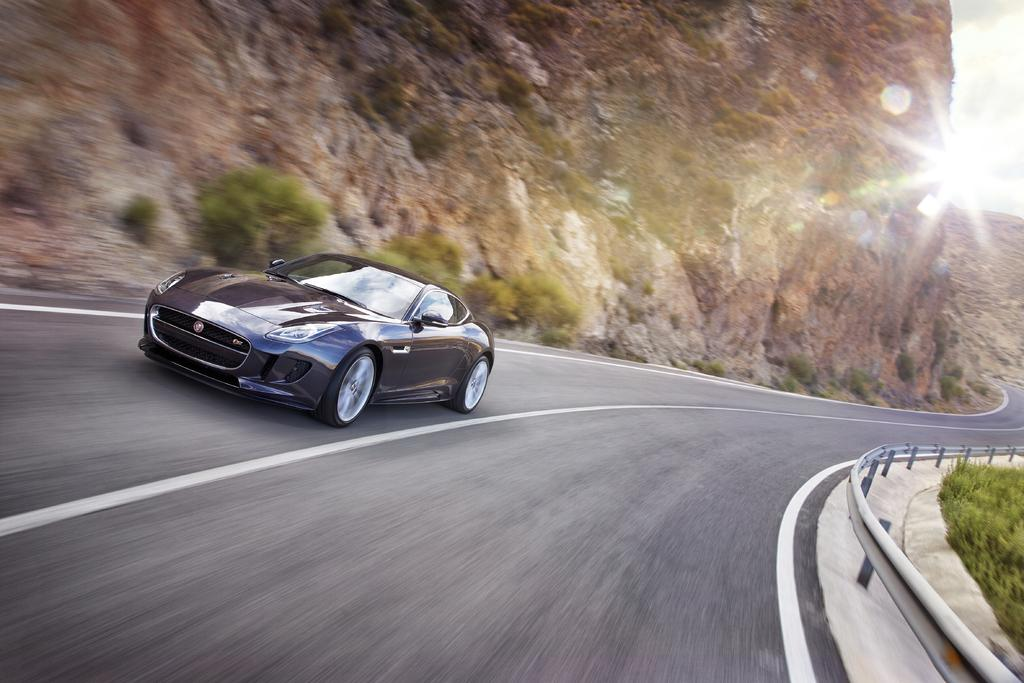What type of vehicle is in the image? There is a black car in the image. What is the car doing in the image? The car is moving on the road. What can be seen in the background of the image? There are hills and trees in the background of the image. What is the boundary visible in the image? The boundary could be a fence, a wall, or a curb that separates the road from the surrounding area. How many cattle are grazing on the line in the image? There are no cattle or lines present in the image. Is there a bike visible in the image? No, there is no bike visible in the image. 